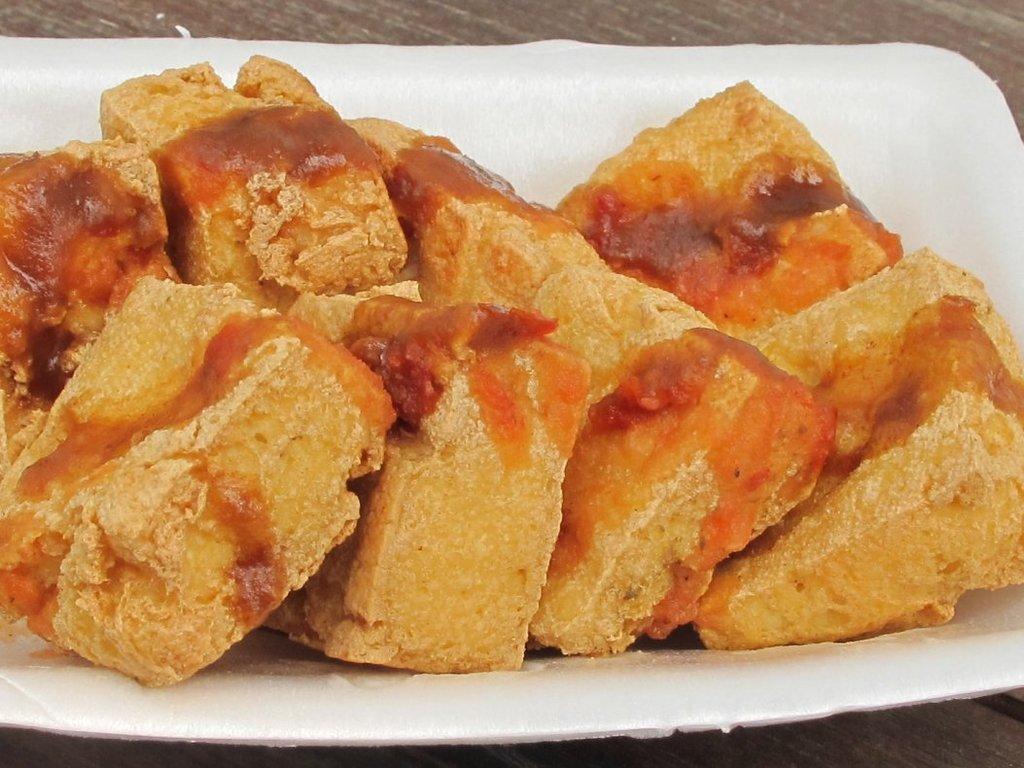What object is present on the plate in the image? There are food items on the plate in the image. What is the color of the plate? The plate is white in color. How many trains can be seen on the plate in the image? There are no trains present on the plate in the image. What type of operation is being performed on the yak in the image? There is no yak present in the image, so no operation is being performed. 